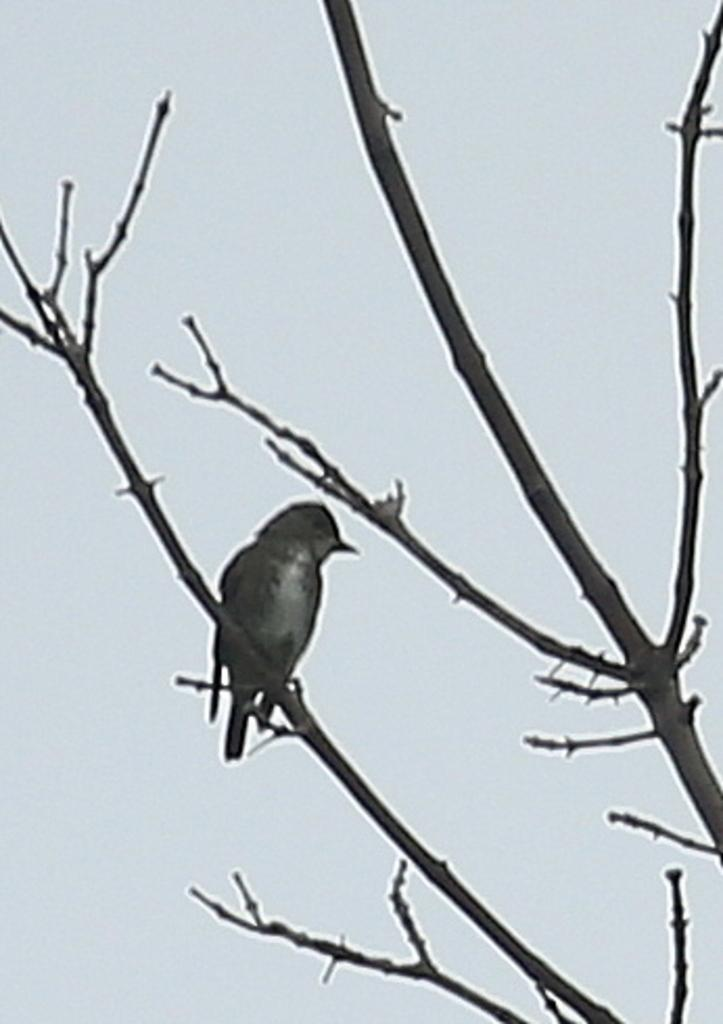What type of animal can be seen in the image? There is a bird in the image. Where is the bird located? The bird is standing on a branch of a tree. What can be seen in the background of the image? There is sky visible in the background of the image. What type of linen is being used to measure the bird's wingspan in the image? There is no linen or measurement of the bird's wingspan present in the image. 